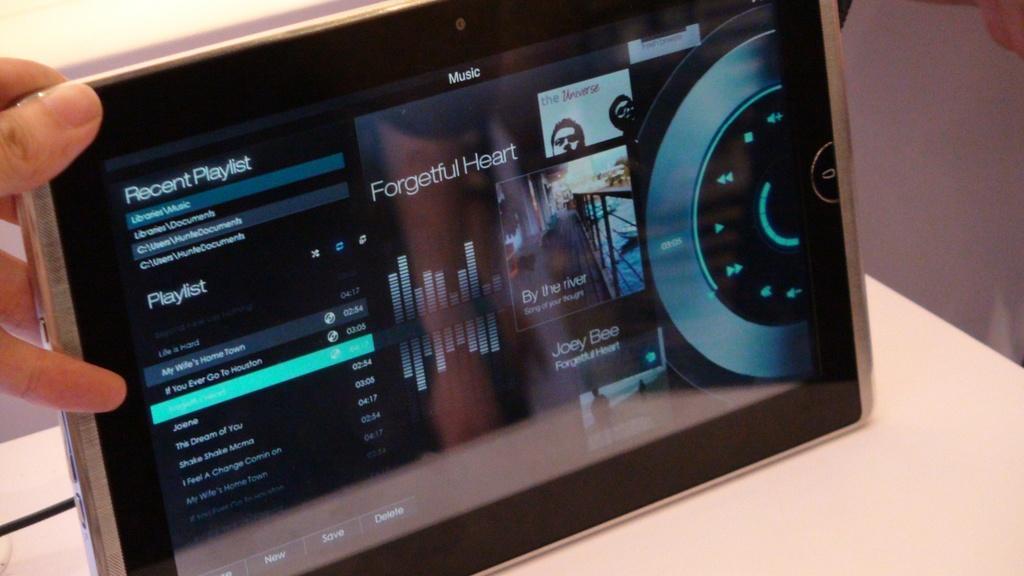Can you describe this image briefly? In this picture we can see the fingers of a person and the person is holding a device. 